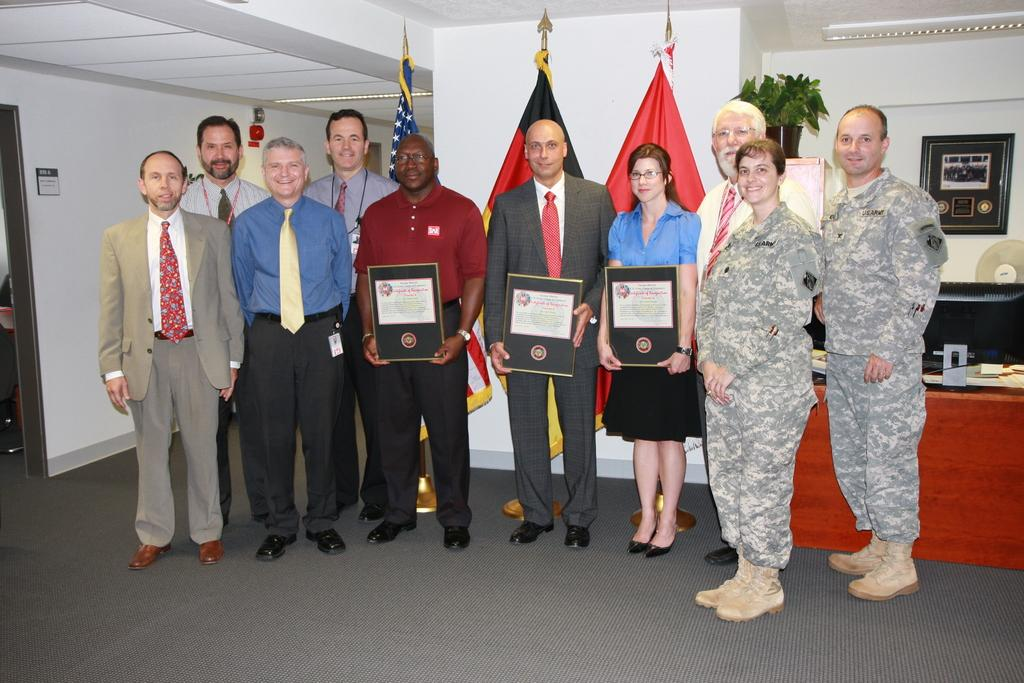What is happening in the image involving the group of people? The people in the image are standing in the front and holding awards in their hands. How many flags can be seen in the image? There are three flags visible in the image. What is the background of the image? There is a white wall in the background. What type of shop can be seen in the image? There is no shop present in the image. Can you describe the bun on the head of one of the people in the image? There is no bun on the head of any person in the image. 